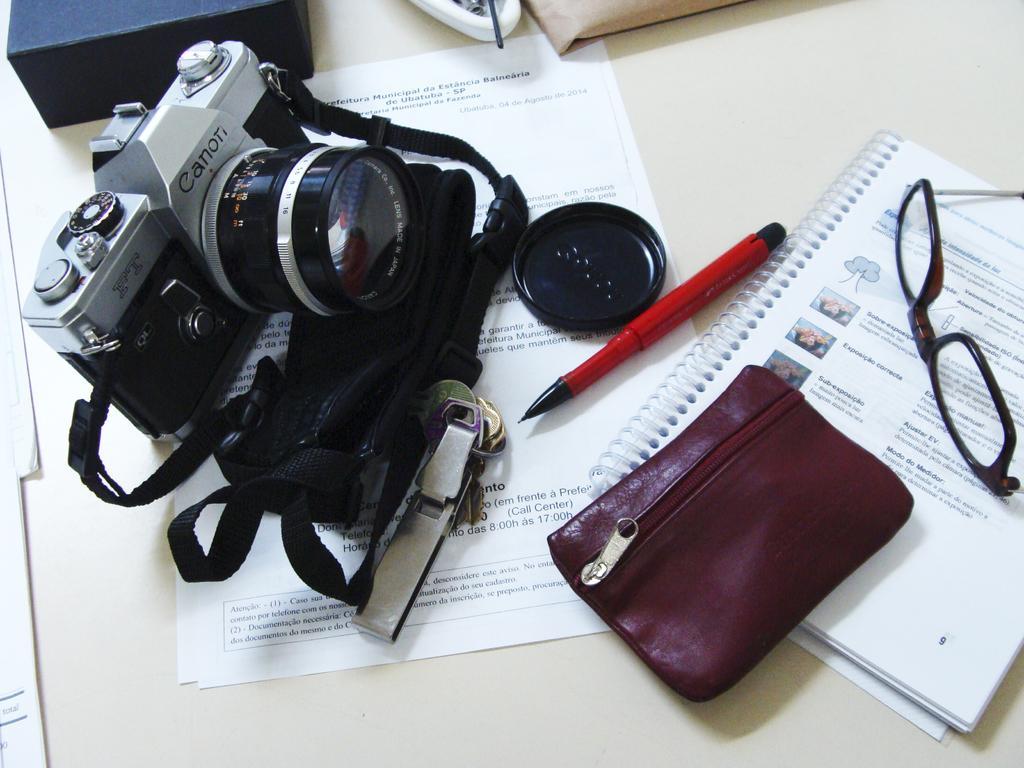Please provide a concise description of this image. In this image we can see a camera, pen, spectacles, papers ,book and a wallet placed on the surface. 